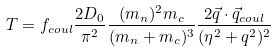<formula> <loc_0><loc_0><loc_500><loc_500>T = f _ { c o u l } \frac { 2 D _ { 0 } } { \pi ^ { 2 } } \frac { ( m _ { n } ) ^ { 2 } m _ { c } } { ( m _ { n } + m _ { c } ) ^ { 3 } } \frac { 2 \vec { q } \cdot \vec { q } _ { c o u l } } { ( \eta ^ { 2 } + q ^ { 2 } ) ^ { 2 } }</formula> 